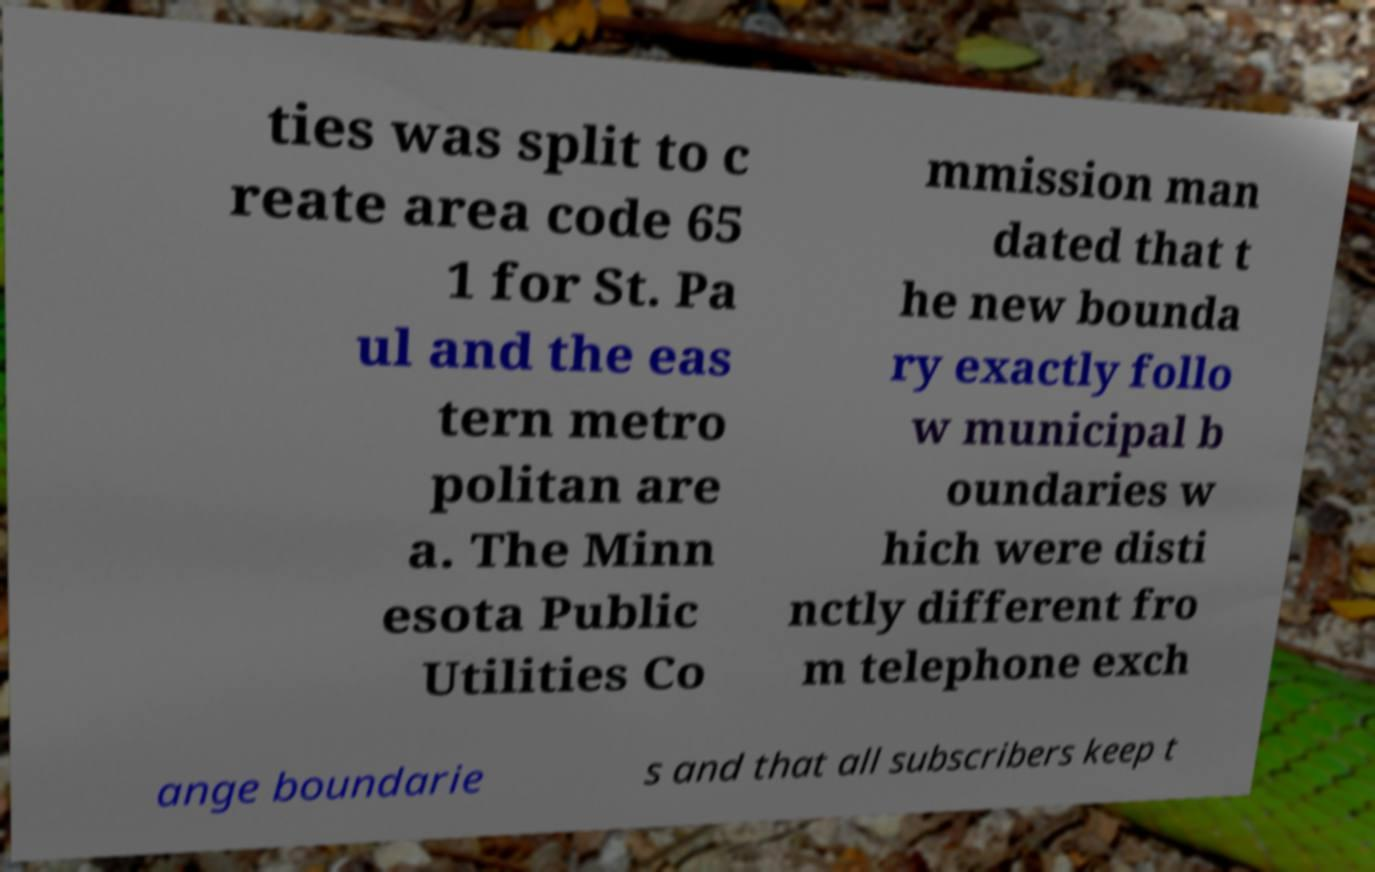Can you accurately transcribe the text from the provided image for me? ties was split to c reate area code 65 1 for St. Pa ul and the eas tern metro politan are a. The Minn esota Public Utilities Co mmission man dated that t he new bounda ry exactly follo w municipal b oundaries w hich were disti nctly different fro m telephone exch ange boundarie s and that all subscribers keep t 